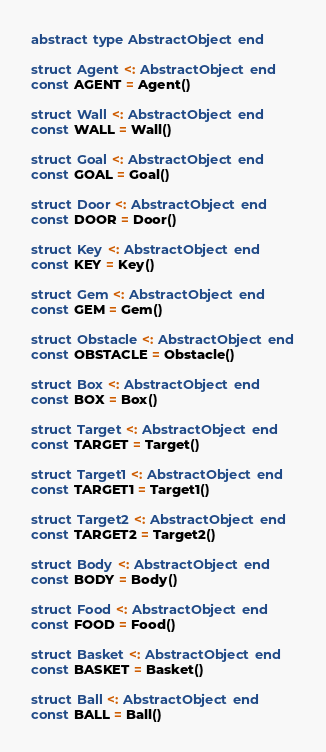Convert code to text. <code><loc_0><loc_0><loc_500><loc_500><_Julia_>abstract type AbstractObject end

struct Agent <: AbstractObject end
const AGENT = Agent()

struct Wall <: AbstractObject end
const WALL = Wall()

struct Goal <: AbstractObject end
const GOAL = Goal()

struct Door <: AbstractObject end
const DOOR = Door()

struct Key <: AbstractObject end
const KEY = Key()

struct Gem <: AbstractObject end
const GEM = Gem()

struct Obstacle <: AbstractObject end
const OBSTACLE = Obstacle()

struct Box <: AbstractObject end
const BOX = Box()

struct Target <: AbstractObject end
const TARGET = Target()

struct Target1 <: AbstractObject end
const TARGET1 = Target1()

struct Target2 <: AbstractObject end
const TARGET2 = Target2()

struct Body <: AbstractObject end
const BODY = Body()

struct Food <: AbstractObject end
const FOOD = Food()

struct Basket <: AbstractObject end
const BASKET = Basket()

struct Ball <: AbstractObject end
const BALL = Ball()
</code> 